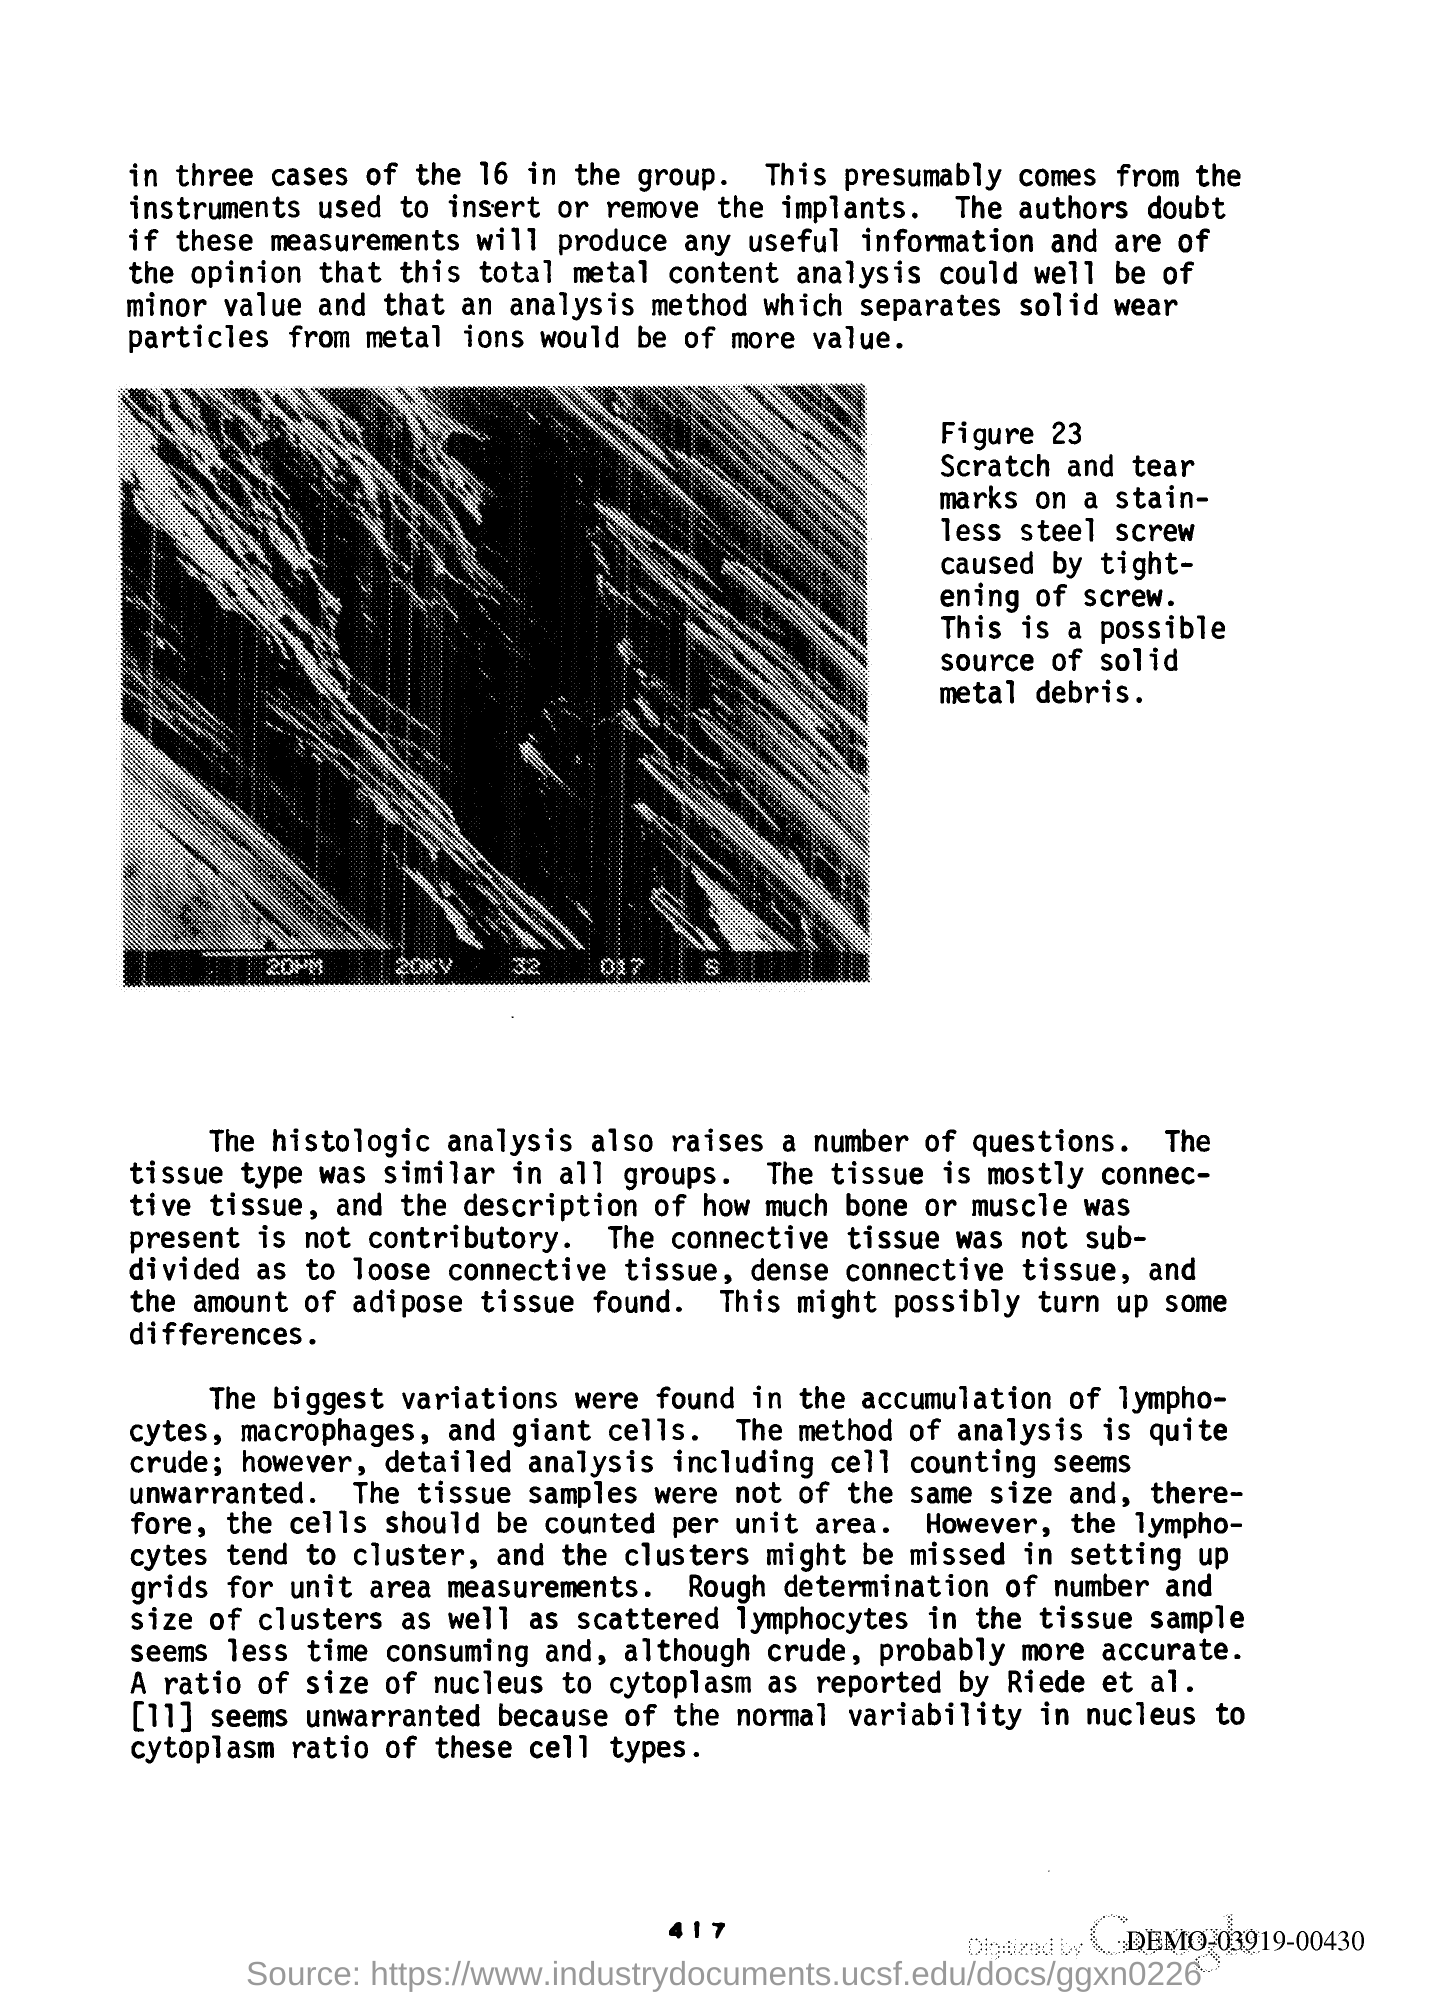Give some essential details in this illustration. The type of tissue that is mostly connective tissue. 